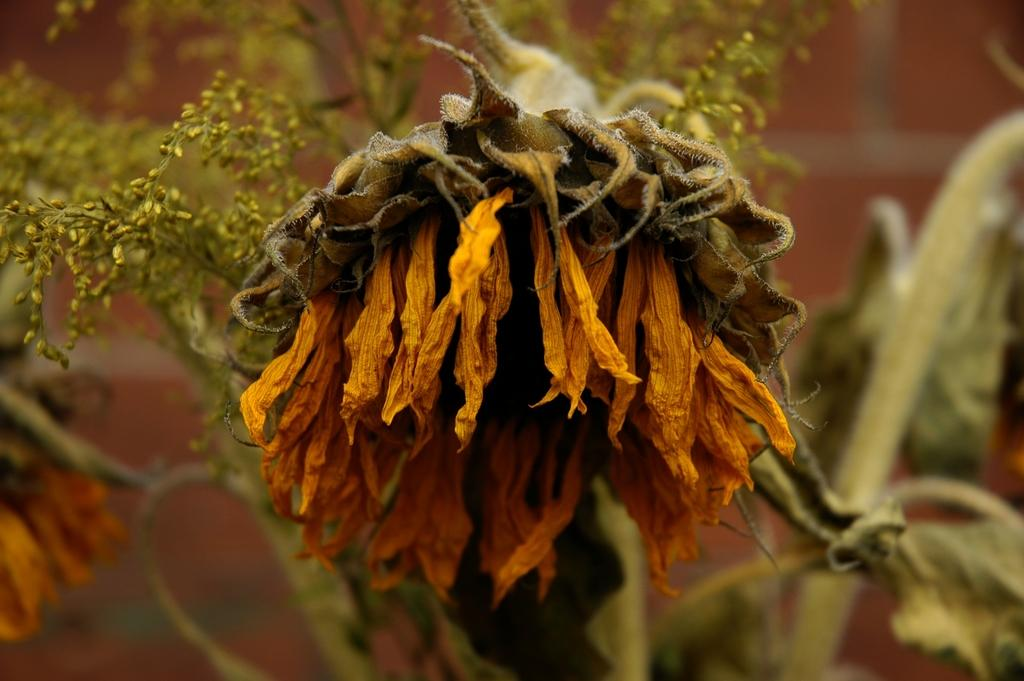Where was the image taken? The image was taken outdoors. What type of vegetation can be seen in the image? There is a plant in the image. What is the main focus of the image? There is a dried sunflower in the middle of the image. What type of wax can be seen dripping from the quince in the image? There is no quince or wax present in the image; it features a dried sunflower. What type of fuel is being used to power the vehicle in the image? There is no vehicle or fuel present in the image; it features a dried sunflower and a plant. 